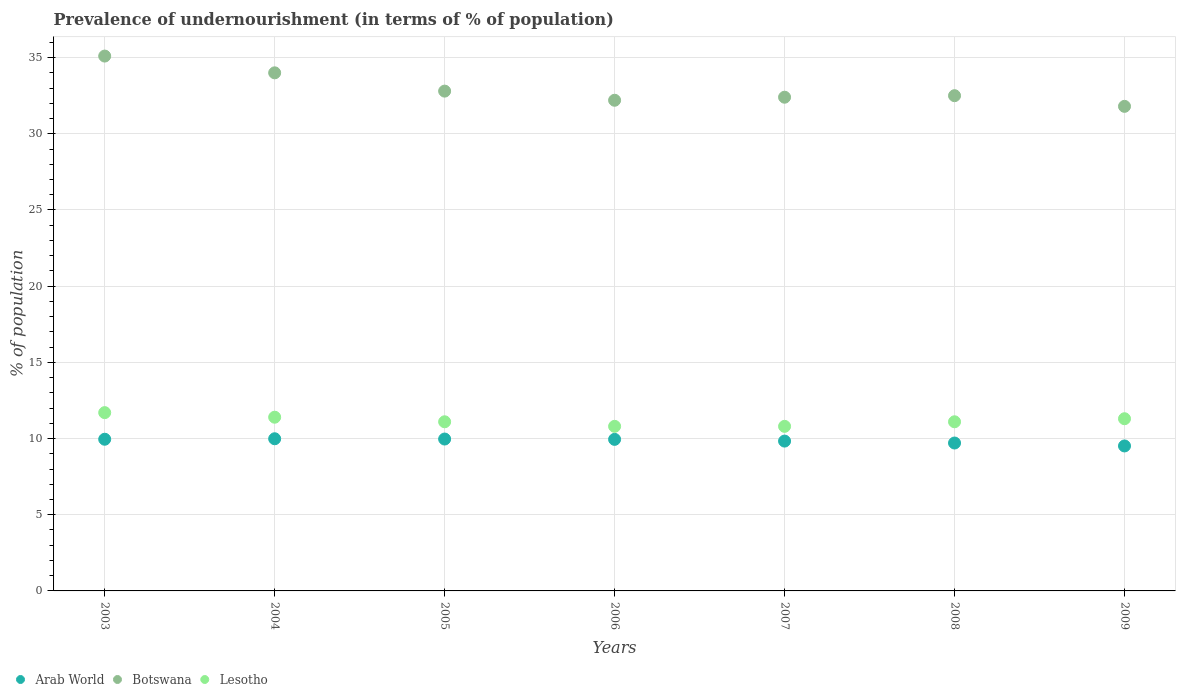Is the number of dotlines equal to the number of legend labels?
Offer a very short reply. Yes. Across all years, what is the maximum percentage of undernourished population in Arab World?
Give a very brief answer. 9.99. Across all years, what is the minimum percentage of undernourished population in Arab World?
Make the answer very short. 9.51. What is the total percentage of undernourished population in Botswana in the graph?
Your answer should be very brief. 230.8. What is the difference between the percentage of undernourished population in Arab World in 2003 and that in 2007?
Provide a succinct answer. 0.12. What is the difference between the percentage of undernourished population in Arab World in 2005 and the percentage of undernourished population in Lesotho in 2008?
Ensure brevity in your answer.  -1.13. What is the average percentage of undernourished population in Botswana per year?
Provide a short and direct response. 32.97. In the year 2008, what is the difference between the percentage of undernourished population in Arab World and percentage of undernourished population in Lesotho?
Provide a succinct answer. -1.39. What is the ratio of the percentage of undernourished population in Botswana in 2005 to that in 2009?
Your answer should be very brief. 1.03. What is the difference between the highest and the second highest percentage of undernourished population in Arab World?
Provide a succinct answer. 0.02. What is the difference between the highest and the lowest percentage of undernourished population in Lesotho?
Your answer should be very brief. 0.9. In how many years, is the percentage of undernourished population in Lesotho greater than the average percentage of undernourished population in Lesotho taken over all years?
Your response must be concise. 3. Is it the case that in every year, the sum of the percentage of undernourished population in Lesotho and percentage of undernourished population in Botswana  is greater than the percentage of undernourished population in Arab World?
Your response must be concise. Yes. Does the percentage of undernourished population in Lesotho monotonically increase over the years?
Your answer should be compact. No. How many years are there in the graph?
Provide a succinct answer. 7. What is the difference between two consecutive major ticks on the Y-axis?
Keep it short and to the point. 5. Does the graph contain any zero values?
Your answer should be very brief. No. Where does the legend appear in the graph?
Provide a succinct answer. Bottom left. How many legend labels are there?
Offer a very short reply. 3. How are the legend labels stacked?
Your response must be concise. Horizontal. What is the title of the graph?
Provide a succinct answer. Prevalence of undernourishment (in terms of % of population). Does "Fiji" appear as one of the legend labels in the graph?
Provide a succinct answer. No. What is the label or title of the Y-axis?
Offer a very short reply. % of population. What is the % of population in Arab World in 2003?
Keep it short and to the point. 9.95. What is the % of population in Botswana in 2003?
Give a very brief answer. 35.1. What is the % of population in Arab World in 2004?
Make the answer very short. 9.99. What is the % of population in Botswana in 2004?
Your response must be concise. 34. What is the % of population of Lesotho in 2004?
Offer a very short reply. 11.4. What is the % of population in Arab World in 2005?
Provide a succinct answer. 9.97. What is the % of population in Botswana in 2005?
Make the answer very short. 32.8. What is the % of population of Arab World in 2006?
Provide a succinct answer. 9.95. What is the % of population of Botswana in 2006?
Your response must be concise. 32.2. What is the % of population in Arab World in 2007?
Keep it short and to the point. 9.83. What is the % of population of Botswana in 2007?
Keep it short and to the point. 32.4. What is the % of population in Lesotho in 2007?
Keep it short and to the point. 10.8. What is the % of population of Arab World in 2008?
Make the answer very short. 9.71. What is the % of population of Botswana in 2008?
Offer a very short reply. 32.5. What is the % of population of Lesotho in 2008?
Offer a terse response. 11.1. What is the % of population of Arab World in 2009?
Your answer should be compact. 9.51. What is the % of population in Botswana in 2009?
Your response must be concise. 31.8. What is the % of population of Lesotho in 2009?
Offer a terse response. 11.3. Across all years, what is the maximum % of population of Arab World?
Provide a succinct answer. 9.99. Across all years, what is the maximum % of population in Botswana?
Give a very brief answer. 35.1. Across all years, what is the maximum % of population in Lesotho?
Keep it short and to the point. 11.7. Across all years, what is the minimum % of population of Arab World?
Give a very brief answer. 9.51. Across all years, what is the minimum % of population of Botswana?
Offer a terse response. 31.8. Across all years, what is the minimum % of population of Lesotho?
Keep it short and to the point. 10.8. What is the total % of population in Arab World in the graph?
Your answer should be very brief. 68.91. What is the total % of population of Botswana in the graph?
Your answer should be very brief. 230.8. What is the total % of population of Lesotho in the graph?
Offer a terse response. 78.2. What is the difference between the % of population of Arab World in 2003 and that in 2004?
Keep it short and to the point. -0.03. What is the difference between the % of population of Arab World in 2003 and that in 2005?
Keep it short and to the point. -0.01. What is the difference between the % of population of Botswana in 2003 and that in 2005?
Offer a very short reply. 2.3. What is the difference between the % of population in Arab World in 2003 and that in 2006?
Give a very brief answer. 0.01. What is the difference between the % of population in Botswana in 2003 and that in 2006?
Your response must be concise. 2.9. What is the difference between the % of population in Arab World in 2003 and that in 2007?
Keep it short and to the point. 0.12. What is the difference between the % of population in Lesotho in 2003 and that in 2007?
Provide a short and direct response. 0.9. What is the difference between the % of population in Arab World in 2003 and that in 2008?
Ensure brevity in your answer.  0.25. What is the difference between the % of population of Botswana in 2003 and that in 2008?
Provide a short and direct response. 2.6. What is the difference between the % of population in Lesotho in 2003 and that in 2008?
Your response must be concise. 0.6. What is the difference between the % of population in Arab World in 2003 and that in 2009?
Offer a terse response. 0.44. What is the difference between the % of population in Arab World in 2004 and that in 2005?
Offer a terse response. 0.02. What is the difference between the % of population of Arab World in 2004 and that in 2006?
Your answer should be very brief. 0.04. What is the difference between the % of population of Botswana in 2004 and that in 2006?
Provide a short and direct response. 1.8. What is the difference between the % of population of Arab World in 2004 and that in 2007?
Your answer should be compact. 0.15. What is the difference between the % of population in Botswana in 2004 and that in 2007?
Offer a very short reply. 1.6. What is the difference between the % of population in Arab World in 2004 and that in 2008?
Provide a succinct answer. 0.28. What is the difference between the % of population in Lesotho in 2004 and that in 2008?
Offer a terse response. 0.3. What is the difference between the % of population in Arab World in 2004 and that in 2009?
Make the answer very short. 0.47. What is the difference between the % of population of Botswana in 2004 and that in 2009?
Your answer should be compact. 2.2. What is the difference between the % of population in Arab World in 2005 and that in 2006?
Give a very brief answer. 0.02. What is the difference between the % of population in Botswana in 2005 and that in 2006?
Your answer should be very brief. 0.6. What is the difference between the % of population in Arab World in 2005 and that in 2007?
Keep it short and to the point. 0.13. What is the difference between the % of population of Lesotho in 2005 and that in 2007?
Your answer should be very brief. 0.3. What is the difference between the % of population of Arab World in 2005 and that in 2008?
Your answer should be very brief. 0.26. What is the difference between the % of population in Arab World in 2005 and that in 2009?
Make the answer very short. 0.45. What is the difference between the % of population in Botswana in 2005 and that in 2009?
Give a very brief answer. 1. What is the difference between the % of population in Lesotho in 2005 and that in 2009?
Your response must be concise. -0.2. What is the difference between the % of population of Arab World in 2006 and that in 2007?
Make the answer very short. 0.11. What is the difference between the % of population of Lesotho in 2006 and that in 2007?
Your answer should be very brief. 0. What is the difference between the % of population of Arab World in 2006 and that in 2008?
Your answer should be compact. 0.24. What is the difference between the % of population of Lesotho in 2006 and that in 2008?
Make the answer very short. -0.3. What is the difference between the % of population of Arab World in 2006 and that in 2009?
Keep it short and to the point. 0.43. What is the difference between the % of population in Botswana in 2006 and that in 2009?
Your answer should be very brief. 0.4. What is the difference between the % of population of Lesotho in 2006 and that in 2009?
Make the answer very short. -0.5. What is the difference between the % of population of Arab World in 2007 and that in 2008?
Provide a succinct answer. 0.13. What is the difference between the % of population of Lesotho in 2007 and that in 2008?
Keep it short and to the point. -0.3. What is the difference between the % of population of Arab World in 2007 and that in 2009?
Offer a terse response. 0.32. What is the difference between the % of population of Lesotho in 2007 and that in 2009?
Make the answer very short. -0.5. What is the difference between the % of population in Arab World in 2008 and that in 2009?
Ensure brevity in your answer.  0.19. What is the difference between the % of population in Lesotho in 2008 and that in 2009?
Offer a terse response. -0.2. What is the difference between the % of population in Arab World in 2003 and the % of population in Botswana in 2004?
Your answer should be compact. -24.05. What is the difference between the % of population of Arab World in 2003 and the % of population of Lesotho in 2004?
Give a very brief answer. -1.45. What is the difference between the % of population in Botswana in 2003 and the % of population in Lesotho in 2004?
Keep it short and to the point. 23.7. What is the difference between the % of population of Arab World in 2003 and the % of population of Botswana in 2005?
Your response must be concise. -22.85. What is the difference between the % of population in Arab World in 2003 and the % of population in Lesotho in 2005?
Your answer should be very brief. -1.15. What is the difference between the % of population in Botswana in 2003 and the % of population in Lesotho in 2005?
Offer a terse response. 24. What is the difference between the % of population of Arab World in 2003 and the % of population of Botswana in 2006?
Provide a succinct answer. -22.25. What is the difference between the % of population of Arab World in 2003 and the % of population of Lesotho in 2006?
Give a very brief answer. -0.85. What is the difference between the % of population in Botswana in 2003 and the % of population in Lesotho in 2006?
Give a very brief answer. 24.3. What is the difference between the % of population of Arab World in 2003 and the % of population of Botswana in 2007?
Ensure brevity in your answer.  -22.45. What is the difference between the % of population in Arab World in 2003 and the % of population in Lesotho in 2007?
Your response must be concise. -0.85. What is the difference between the % of population in Botswana in 2003 and the % of population in Lesotho in 2007?
Keep it short and to the point. 24.3. What is the difference between the % of population in Arab World in 2003 and the % of population in Botswana in 2008?
Your answer should be very brief. -22.55. What is the difference between the % of population in Arab World in 2003 and the % of population in Lesotho in 2008?
Ensure brevity in your answer.  -1.15. What is the difference between the % of population in Arab World in 2003 and the % of population in Botswana in 2009?
Ensure brevity in your answer.  -21.85. What is the difference between the % of population in Arab World in 2003 and the % of population in Lesotho in 2009?
Offer a very short reply. -1.35. What is the difference between the % of population in Botswana in 2003 and the % of population in Lesotho in 2009?
Keep it short and to the point. 23.8. What is the difference between the % of population in Arab World in 2004 and the % of population in Botswana in 2005?
Ensure brevity in your answer.  -22.81. What is the difference between the % of population of Arab World in 2004 and the % of population of Lesotho in 2005?
Ensure brevity in your answer.  -1.11. What is the difference between the % of population of Botswana in 2004 and the % of population of Lesotho in 2005?
Your answer should be compact. 22.9. What is the difference between the % of population of Arab World in 2004 and the % of population of Botswana in 2006?
Ensure brevity in your answer.  -22.21. What is the difference between the % of population in Arab World in 2004 and the % of population in Lesotho in 2006?
Your answer should be very brief. -0.81. What is the difference between the % of population of Botswana in 2004 and the % of population of Lesotho in 2006?
Give a very brief answer. 23.2. What is the difference between the % of population of Arab World in 2004 and the % of population of Botswana in 2007?
Keep it short and to the point. -22.41. What is the difference between the % of population in Arab World in 2004 and the % of population in Lesotho in 2007?
Offer a terse response. -0.81. What is the difference between the % of population of Botswana in 2004 and the % of population of Lesotho in 2007?
Provide a succinct answer. 23.2. What is the difference between the % of population of Arab World in 2004 and the % of population of Botswana in 2008?
Give a very brief answer. -22.51. What is the difference between the % of population of Arab World in 2004 and the % of population of Lesotho in 2008?
Your response must be concise. -1.11. What is the difference between the % of population of Botswana in 2004 and the % of population of Lesotho in 2008?
Offer a terse response. 22.9. What is the difference between the % of population in Arab World in 2004 and the % of population in Botswana in 2009?
Provide a short and direct response. -21.81. What is the difference between the % of population in Arab World in 2004 and the % of population in Lesotho in 2009?
Provide a succinct answer. -1.31. What is the difference between the % of population of Botswana in 2004 and the % of population of Lesotho in 2009?
Your answer should be very brief. 22.7. What is the difference between the % of population of Arab World in 2005 and the % of population of Botswana in 2006?
Offer a terse response. -22.23. What is the difference between the % of population of Arab World in 2005 and the % of population of Lesotho in 2006?
Keep it short and to the point. -0.83. What is the difference between the % of population of Arab World in 2005 and the % of population of Botswana in 2007?
Provide a succinct answer. -22.43. What is the difference between the % of population of Arab World in 2005 and the % of population of Lesotho in 2007?
Offer a terse response. -0.83. What is the difference between the % of population in Botswana in 2005 and the % of population in Lesotho in 2007?
Make the answer very short. 22. What is the difference between the % of population in Arab World in 2005 and the % of population in Botswana in 2008?
Keep it short and to the point. -22.53. What is the difference between the % of population of Arab World in 2005 and the % of population of Lesotho in 2008?
Provide a succinct answer. -1.13. What is the difference between the % of population in Botswana in 2005 and the % of population in Lesotho in 2008?
Give a very brief answer. 21.7. What is the difference between the % of population of Arab World in 2005 and the % of population of Botswana in 2009?
Offer a terse response. -21.83. What is the difference between the % of population of Arab World in 2005 and the % of population of Lesotho in 2009?
Your answer should be compact. -1.33. What is the difference between the % of population in Arab World in 2006 and the % of population in Botswana in 2007?
Offer a terse response. -22.45. What is the difference between the % of population of Arab World in 2006 and the % of population of Lesotho in 2007?
Your answer should be very brief. -0.85. What is the difference between the % of population of Botswana in 2006 and the % of population of Lesotho in 2007?
Provide a short and direct response. 21.4. What is the difference between the % of population of Arab World in 2006 and the % of population of Botswana in 2008?
Offer a terse response. -22.55. What is the difference between the % of population of Arab World in 2006 and the % of population of Lesotho in 2008?
Offer a terse response. -1.15. What is the difference between the % of population in Botswana in 2006 and the % of population in Lesotho in 2008?
Your answer should be compact. 21.1. What is the difference between the % of population in Arab World in 2006 and the % of population in Botswana in 2009?
Provide a short and direct response. -21.85. What is the difference between the % of population in Arab World in 2006 and the % of population in Lesotho in 2009?
Your response must be concise. -1.35. What is the difference between the % of population in Botswana in 2006 and the % of population in Lesotho in 2009?
Provide a succinct answer. 20.9. What is the difference between the % of population in Arab World in 2007 and the % of population in Botswana in 2008?
Your answer should be very brief. -22.67. What is the difference between the % of population in Arab World in 2007 and the % of population in Lesotho in 2008?
Offer a terse response. -1.27. What is the difference between the % of population of Botswana in 2007 and the % of population of Lesotho in 2008?
Ensure brevity in your answer.  21.3. What is the difference between the % of population of Arab World in 2007 and the % of population of Botswana in 2009?
Offer a terse response. -21.97. What is the difference between the % of population in Arab World in 2007 and the % of population in Lesotho in 2009?
Your answer should be very brief. -1.47. What is the difference between the % of population in Botswana in 2007 and the % of population in Lesotho in 2009?
Offer a terse response. 21.1. What is the difference between the % of population of Arab World in 2008 and the % of population of Botswana in 2009?
Provide a short and direct response. -22.09. What is the difference between the % of population in Arab World in 2008 and the % of population in Lesotho in 2009?
Your answer should be very brief. -1.59. What is the difference between the % of population in Botswana in 2008 and the % of population in Lesotho in 2009?
Offer a very short reply. 21.2. What is the average % of population in Arab World per year?
Provide a succinct answer. 9.84. What is the average % of population of Botswana per year?
Your answer should be compact. 32.97. What is the average % of population of Lesotho per year?
Your response must be concise. 11.17. In the year 2003, what is the difference between the % of population of Arab World and % of population of Botswana?
Provide a succinct answer. -25.15. In the year 2003, what is the difference between the % of population of Arab World and % of population of Lesotho?
Keep it short and to the point. -1.75. In the year 2003, what is the difference between the % of population of Botswana and % of population of Lesotho?
Offer a terse response. 23.4. In the year 2004, what is the difference between the % of population of Arab World and % of population of Botswana?
Ensure brevity in your answer.  -24.01. In the year 2004, what is the difference between the % of population of Arab World and % of population of Lesotho?
Offer a very short reply. -1.41. In the year 2004, what is the difference between the % of population in Botswana and % of population in Lesotho?
Offer a very short reply. 22.6. In the year 2005, what is the difference between the % of population in Arab World and % of population in Botswana?
Offer a terse response. -22.83. In the year 2005, what is the difference between the % of population of Arab World and % of population of Lesotho?
Offer a very short reply. -1.13. In the year 2005, what is the difference between the % of population of Botswana and % of population of Lesotho?
Your response must be concise. 21.7. In the year 2006, what is the difference between the % of population in Arab World and % of population in Botswana?
Offer a very short reply. -22.25. In the year 2006, what is the difference between the % of population in Arab World and % of population in Lesotho?
Provide a short and direct response. -0.85. In the year 2006, what is the difference between the % of population in Botswana and % of population in Lesotho?
Give a very brief answer. 21.4. In the year 2007, what is the difference between the % of population in Arab World and % of population in Botswana?
Offer a very short reply. -22.57. In the year 2007, what is the difference between the % of population of Arab World and % of population of Lesotho?
Give a very brief answer. -0.97. In the year 2007, what is the difference between the % of population in Botswana and % of population in Lesotho?
Keep it short and to the point. 21.6. In the year 2008, what is the difference between the % of population of Arab World and % of population of Botswana?
Give a very brief answer. -22.79. In the year 2008, what is the difference between the % of population of Arab World and % of population of Lesotho?
Offer a terse response. -1.39. In the year 2008, what is the difference between the % of population of Botswana and % of population of Lesotho?
Offer a terse response. 21.4. In the year 2009, what is the difference between the % of population of Arab World and % of population of Botswana?
Provide a short and direct response. -22.29. In the year 2009, what is the difference between the % of population of Arab World and % of population of Lesotho?
Provide a short and direct response. -1.79. In the year 2009, what is the difference between the % of population of Botswana and % of population of Lesotho?
Your answer should be compact. 20.5. What is the ratio of the % of population of Botswana in 2003 to that in 2004?
Your answer should be compact. 1.03. What is the ratio of the % of population of Lesotho in 2003 to that in 2004?
Offer a very short reply. 1.03. What is the ratio of the % of population of Arab World in 2003 to that in 2005?
Your response must be concise. 1. What is the ratio of the % of population of Botswana in 2003 to that in 2005?
Your response must be concise. 1.07. What is the ratio of the % of population in Lesotho in 2003 to that in 2005?
Provide a short and direct response. 1.05. What is the ratio of the % of population in Botswana in 2003 to that in 2006?
Give a very brief answer. 1.09. What is the ratio of the % of population in Lesotho in 2003 to that in 2006?
Keep it short and to the point. 1.08. What is the ratio of the % of population in Arab World in 2003 to that in 2007?
Provide a succinct answer. 1.01. What is the ratio of the % of population of Botswana in 2003 to that in 2007?
Your answer should be very brief. 1.08. What is the ratio of the % of population of Lesotho in 2003 to that in 2007?
Offer a very short reply. 1.08. What is the ratio of the % of population in Arab World in 2003 to that in 2008?
Make the answer very short. 1.03. What is the ratio of the % of population in Lesotho in 2003 to that in 2008?
Offer a terse response. 1.05. What is the ratio of the % of population in Arab World in 2003 to that in 2009?
Your response must be concise. 1.05. What is the ratio of the % of population in Botswana in 2003 to that in 2009?
Offer a terse response. 1.1. What is the ratio of the % of population in Lesotho in 2003 to that in 2009?
Offer a very short reply. 1.04. What is the ratio of the % of population in Arab World in 2004 to that in 2005?
Give a very brief answer. 1. What is the ratio of the % of population of Botswana in 2004 to that in 2005?
Provide a succinct answer. 1.04. What is the ratio of the % of population in Lesotho in 2004 to that in 2005?
Make the answer very short. 1.03. What is the ratio of the % of population of Botswana in 2004 to that in 2006?
Provide a short and direct response. 1.06. What is the ratio of the % of population in Lesotho in 2004 to that in 2006?
Offer a very short reply. 1.06. What is the ratio of the % of population in Arab World in 2004 to that in 2007?
Give a very brief answer. 1.02. What is the ratio of the % of population in Botswana in 2004 to that in 2007?
Make the answer very short. 1.05. What is the ratio of the % of population in Lesotho in 2004 to that in 2007?
Your answer should be very brief. 1.06. What is the ratio of the % of population of Arab World in 2004 to that in 2008?
Provide a succinct answer. 1.03. What is the ratio of the % of population of Botswana in 2004 to that in 2008?
Make the answer very short. 1.05. What is the ratio of the % of population in Lesotho in 2004 to that in 2008?
Keep it short and to the point. 1.03. What is the ratio of the % of population of Arab World in 2004 to that in 2009?
Your answer should be very brief. 1.05. What is the ratio of the % of population in Botswana in 2004 to that in 2009?
Make the answer very short. 1.07. What is the ratio of the % of population of Lesotho in 2004 to that in 2009?
Your response must be concise. 1.01. What is the ratio of the % of population of Botswana in 2005 to that in 2006?
Give a very brief answer. 1.02. What is the ratio of the % of population in Lesotho in 2005 to that in 2006?
Offer a very short reply. 1.03. What is the ratio of the % of population in Arab World in 2005 to that in 2007?
Keep it short and to the point. 1.01. What is the ratio of the % of population in Botswana in 2005 to that in 2007?
Your response must be concise. 1.01. What is the ratio of the % of population in Lesotho in 2005 to that in 2007?
Your answer should be very brief. 1.03. What is the ratio of the % of population in Arab World in 2005 to that in 2008?
Keep it short and to the point. 1.03. What is the ratio of the % of population of Botswana in 2005 to that in 2008?
Your answer should be compact. 1.01. What is the ratio of the % of population of Arab World in 2005 to that in 2009?
Your answer should be very brief. 1.05. What is the ratio of the % of population in Botswana in 2005 to that in 2009?
Keep it short and to the point. 1.03. What is the ratio of the % of population of Lesotho in 2005 to that in 2009?
Offer a very short reply. 0.98. What is the ratio of the % of population in Arab World in 2006 to that in 2007?
Ensure brevity in your answer.  1.01. What is the ratio of the % of population in Arab World in 2006 to that in 2008?
Your answer should be compact. 1.02. What is the ratio of the % of population of Lesotho in 2006 to that in 2008?
Give a very brief answer. 0.97. What is the ratio of the % of population in Arab World in 2006 to that in 2009?
Provide a succinct answer. 1.05. What is the ratio of the % of population of Botswana in 2006 to that in 2009?
Provide a succinct answer. 1.01. What is the ratio of the % of population of Lesotho in 2006 to that in 2009?
Ensure brevity in your answer.  0.96. What is the ratio of the % of population of Botswana in 2007 to that in 2008?
Provide a succinct answer. 1. What is the ratio of the % of population in Arab World in 2007 to that in 2009?
Your response must be concise. 1.03. What is the ratio of the % of population of Botswana in 2007 to that in 2009?
Your response must be concise. 1.02. What is the ratio of the % of population of Lesotho in 2007 to that in 2009?
Your answer should be compact. 0.96. What is the ratio of the % of population in Arab World in 2008 to that in 2009?
Give a very brief answer. 1.02. What is the ratio of the % of population in Botswana in 2008 to that in 2009?
Your answer should be very brief. 1.02. What is the ratio of the % of population in Lesotho in 2008 to that in 2009?
Offer a very short reply. 0.98. What is the difference between the highest and the second highest % of population in Arab World?
Offer a terse response. 0.02. What is the difference between the highest and the lowest % of population of Arab World?
Provide a succinct answer. 0.47. What is the difference between the highest and the lowest % of population in Botswana?
Provide a succinct answer. 3.3. What is the difference between the highest and the lowest % of population of Lesotho?
Your answer should be compact. 0.9. 